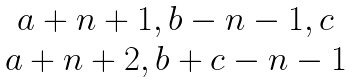Convert formula to latex. <formula><loc_0><loc_0><loc_500><loc_500>\begin{matrix} { a + n + 1 , b - n - 1 , c } \\ { a + n + 2 , b + c - n - 1 } \end{matrix}</formula> 